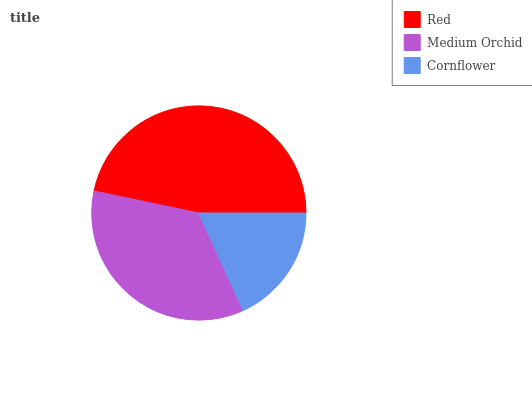Is Cornflower the minimum?
Answer yes or no. Yes. Is Red the maximum?
Answer yes or no. Yes. Is Medium Orchid the minimum?
Answer yes or no. No. Is Medium Orchid the maximum?
Answer yes or no. No. Is Red greater than Medium Orchid?
Answer yes or no. Yes. Is Medium Orchid less than Red?
Answer yes or no. Yes. Is Medium Orchid greater than Red?
Answer yes or no. No. Is Red less than Medium Orchid?
Answer yes or no. No. Is Medium Orchid the high median?
Answer yes or no. Yes. Is Medium Orchid the low median?
Answer yes or no. Yes. Is Red the high median?
Answer yes or no. No. Is Red the low median?
Answer yes or no. No. 